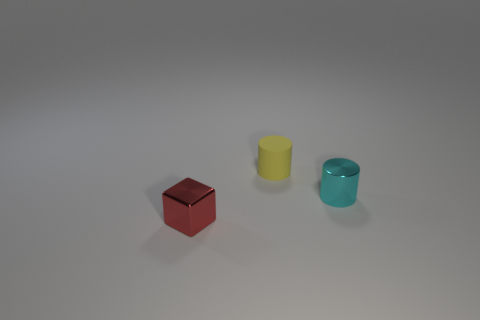Is there any other thing that is the same material as the tiny yellow cylinder?
Provide a short and direct response. No. How many other objects are the same shape as the small rubber object?
Provide a succinct answer. 1. What number of other things are made of the same material as the block?
Offer a very short reply. 1. There is a yellow thing that is the same shape as the cyan object; what is its size?
Keep it short and to the point. Small. Do the small metal cube and the matte cylinder have the same color?
Your answer should be very brief. No. What color is the thing that is to the left of the cyan cylinder and right of the tiny metal block?
Offer a very short reply. Yellow. What number of objects are either shiny things behind the cube or tiny yellow cylinders?
Ensure brevity in your answer.  2. What color is the other tiny matte thing that is the same shape as the tiny cyan object?
Provide a short and direct response. Yellow. Do the yellow rubber thing and the metallic thing behind the block have the same shape?
Keep it short and to the point. Yes. How many objects are either tiny things that are on the left side of the small metallic cylinder or small objects to the right of the small red cube?
Your answer should be compact. 3. 